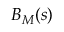<formula> <loc_0><loc_0><loc_500><loc_500>B _ { M } ( s )</formula> 